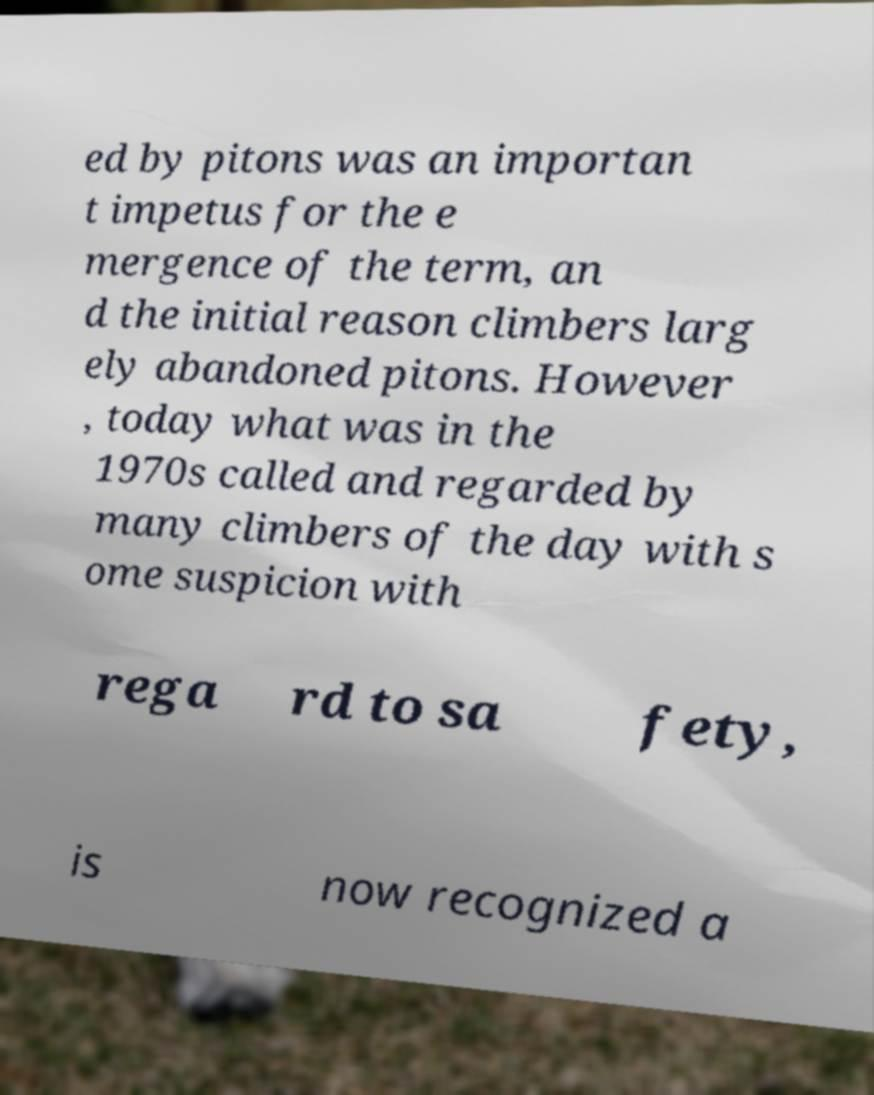For documentation purposes, I need the text within this image transcribed. Could you provide that? ed by pitons was an importan t impetus for the e mergence of the term, an d the initial reason climbers larg ely abandoned pitons. However , today what was in the 1970s called and regarded by many climbers of the day with s ome suspicion with rega rd to sa fety, is now recognized a 